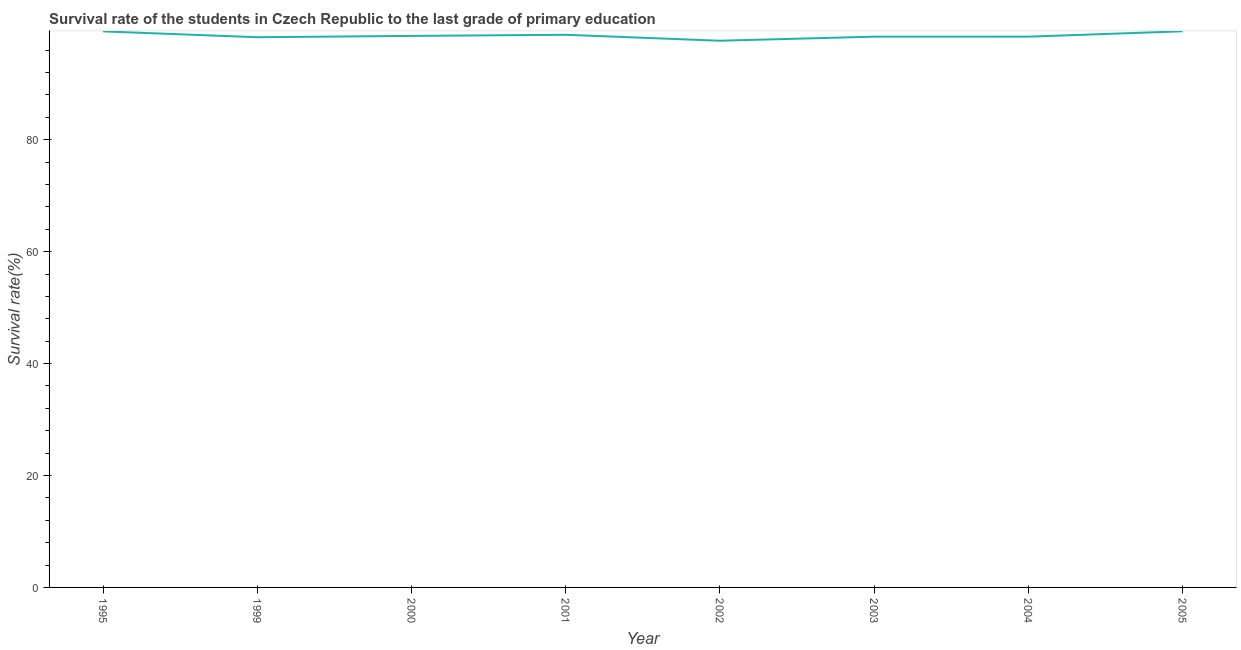What is the survival rate in primary education in 2000?
Provide a short and direct response. 98.55. Across all years, what is the maximum survival rate in primary education?
Your answer should be very brief. 99.37. Across all years, what is the minimum survival rate in primary education?
Provide a short and direct response. 97.68. In which year was the survival rate in primary education minimum?
Your answer should be compact. 2002. What is the sum of the survival rate in primary education?
Your answer should be compact. 788.85. What is the difference between the survival rate in primary education in 1995 and 2003?
Ensure brevity in your answer.  0.94. What is the average survival rate in primary education per year?
Offer a very short reply. 98.61. What is the median survival rate in primary education?
Your answer should be compact. 98.48. Do a majority of the years between 2001 and 2004 (inclusive) have survival rate in primary education greater than 36 %?
Your answer should be very brief. Yes. What is the ratio of the survival rate in primary education in 2001 to that in 2002?
Keep it short and to the point. 1.01. What is the difference between the highest and the second highest survival rate in primary education?
Your answer should be compact. 0.02. What is the difference between the highest and the lowest survival rate in primary education?
Your answer should be very brief. 1.69. How many lines are there?
Provide a succinct answer. 1. What is the difference between two consecutive major ticks on the Y-axis?
Provide a succinct answer. 20. Does the graph contain any zero values?
Offer a very short reply. No. Does the graph contain grids?
Your answer should be compact. No. What is the title of the graph?
Offer a terse response. Survival rate of the students in Czech Republic to the last grade of primary education. What is the label or title of the X-axis?
Offer a terse response. Year. What is the label or title of the Y-axis?
Your response must be concise. Survival rate(%). What is the Survival rate(%) of 1995?
Offer a very short reply. 99.35. What is the Survival rate(%) of 1999?
Provide a short and direct response. 98.31. What is the Survival rate(%) in 2000?
Ensure brevity in your answer.  98.55. What is the Survival rate(%) in 2001?
Provide a succinct answer. 98.75. What is the Survival rate(%) of 2002?
Your response must be concise. 97.68. What is the Survival rate(%) of 2003?
Give a very brief answer. 98.41. What is the Survival rate(%) of 2004?
Make the answer very short. 98.42. What is the Survival rate(%) in 2005?
Keep it short and to the point. 99.37. What is the difference between the Survival rate(%) in 1995 and 1999?
Your answer should be very brief. 1.04. What is the difference between the Survival rate(%) in 1995 and 2000?
Provide a succinct answer. 0.81. What is the difference between the Survival rate(%) in 1995 and 2001?
Keep it short and to the point. 0.61. What is the difference between the Survival rate(%) in 1995 and 2002?
Your answer should be very brief. 1.67. What is the difference between the Survival rate(%) in 1995 and 2003?
Provide a succinct answer. 0.94. What is the difference between the Survival rate(%) in 1995 and 2004?
Offer a very short reply. 0.94. What is the difference between the Survival rate(%) in 1995 and 2005?
Provide a succinct answer. -0.02. What is the difference between the Survival rate(%) in 1999 and 2000?
Provide a succinct answer. -0.24. What is the difference between the Survival rate(%) in 1999 and 2001?
Your answer should be compact. -0.44. What is the difference between the Survival rate(%) in 1999 and 2002?
Give a very brief answer. 0.63. What is the difference between the Survival rate(%) in 1999 and 2003?
Your answer should be very brief. -0.1. What is the difference between the Survival rate(%) in 1999 and 2004?
Keep it short and to the point. -0.1. What is the difference between the Survival rate(%) in 1999 and 2005?
Give a very brief answer. -1.06. What is the difference between the Survival rate(%) in 2000 and 2001?
Keep it short and to the point. -0.2. What is the difference between the Survival rate(%) in 2000 and 2002?
Keep it short and to the point. 0.86. What is the difference between the Survival rate(%) in 2000 and 2003?
Provide a succinct answer. 0.14. What is the difference between the Survival rate(%) in 2000 and 2004?
Keep it short and to the point. 0.13. What is the difference between the Survival rate(%) in 2000 and 2005?
Your answer should be very brief. -0.82. What is the difference between the Survival rate(%) in 2001 and 2002?
Keep it short and to the point. 1.06. What is the difference between the Survival rate(%) in 2001 and 2003?
Give a very brief answer. 0.34. What is the difference between the Survival rate(%) in 2001 and 2004?
Ensure brevity in your answer.  0.33. What is the difference between the Survival rate(%) in 2001 and 2005?
Your response must be concise. -0.62. What is the difference between the Survival rate(%) in 2002 and 2003?
Offer a terse response. -0.73. What is the difference between the Survival rate(%) in 2002 and 2004?
Your answer should be compact. -0.73. What is the difference between the Survival rate(%) in 2002 and 2005?
Offer a terse response. -1.69. What is the difference between the Survival rate(%) in 2003 and 2004?
Give a very brief answer. -0. What is the difference between the Survival rate(%) in 2003 and 2005?
Offer a very short reply. -0.96. What is the difference between the Survival rate(%) in 2004 and 2005?
Offer a very short reply. -0.96. What is the ratio of the Survival rate(%) in 1995 to that in 2005?
Provide a succinct answer. 1. What is the ratio of the Survival rate(%) in 1999 to that in 2000?
Offer a terse response. 1. What is the ratio of the Survival rate(%) in 2000 to that in 2001?
Ensure brevity in your answer.  1. What is the ratio of the Survival rate(%) in 2000 to that in 2002?
Your answer should be very brief. 1.01. What is the ratio of the Survival rate(%) in 2000 to that in 2003?
Give a very brief answer. 1. What is the ratio of the Survival rate(%) in 2000 to that in 2005?
Provide a succinct answer. 0.99. What is the ratio of the Survival rate(%) in 2001 to that in 2003?
Keep it short and to the point. 1. What is the ratio of the Survival rate(%) in 2002 to that in 2003?
Make the answer very short. 0.99. What is the ratio of the Survival rate(%) in 2003 to that in 2004?
Your response must be concise. 1. What is the ratio of the Survival rate(%) in 2003 to that in 2005?
Your answer should be very brief. 0.99. 